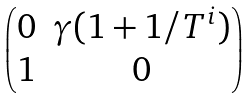Convert formula to latex. <formula><loc_0><loc_0><loc_500><loc_500>\begin{pmatrix} 0 & \gamma ( 1 + 1 / T ^ { i } ) \\ 1 & 0 \end{pmatrix}</formula> 